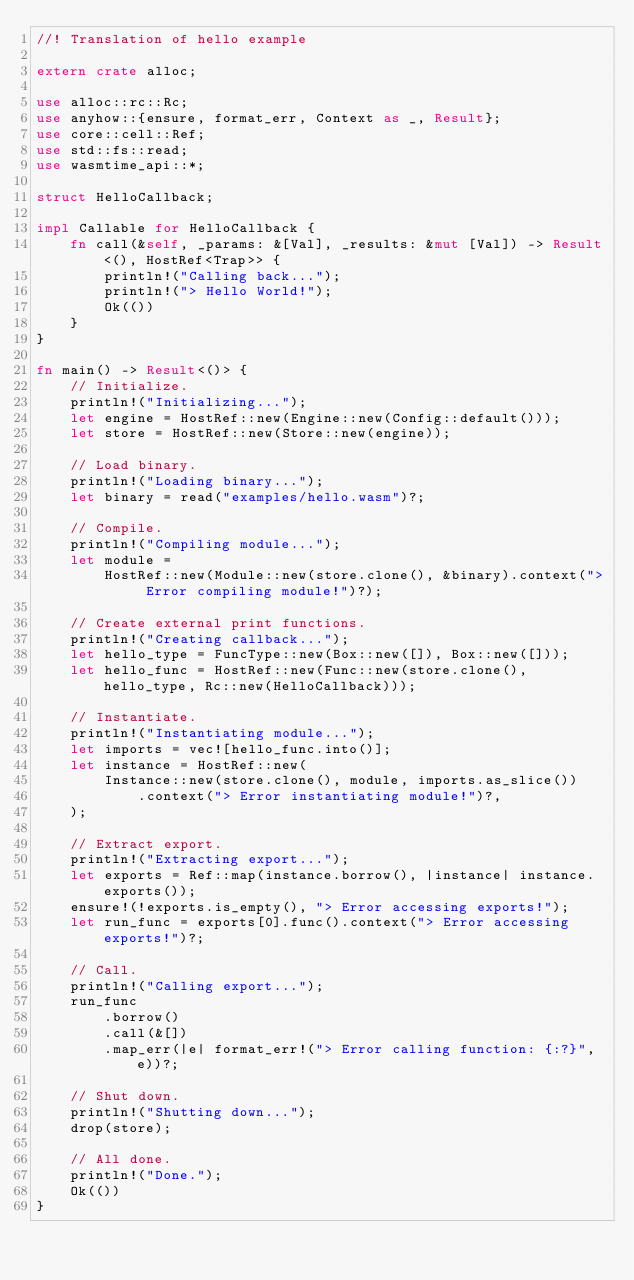<code> <loc_0><loc_0><loc_500><loc_500><_Rust_>//! Translation of hello example

extern crate alloc;

use alloc::rc::Rc;
use anyhow::{ensure, format_err, Context as _, Result};
use core::cell::Ref;
use std::fs::read;
use wasmtime_api::*;

struct HelloCallback;

impl Callable for HelloCallback {
    fn call(&self, _params: &[Val], _results: &mut [Val]) -> Result<(), HostRef<Trap>> {
        println!("Calling back...");
        println!("> Hello World!");
        Ok(())
    }
}

fn main() -> Result<()> {
    // Initialize.
    println!("Initializing...");
    let engine = HostRef::new(Engine::new(Config::default()));
    let store = HostRef::new(Store::new(engine));

    // Load binary.
    println!("Loading binary...");
    let binary = read("examples/hello.wasm")?;

    // Compile.
    println!("Compiling module...");
    let module =
        HostRef::new(Module::new(store.clone(), &binary).context("> Error compiling module!")?);

    // Create external print functions.
    println!("Creating callback...");
    let hello_type = FuncType::new(Box::new([]), Box::new([]));
    let hello_func = HostRef::new(Func::new(store.clone(), hello_type, Rc::new(HelloCallback)));

    // Instantiate.
    println!("Instantiating module...");
    let imports = vec![hello_func.into()];
    let instance = HostRef::new(
        Instance::new(store.clone(), module, imports.as_slice())
            .context("> Error instantiating module!")?,
    );

    // Extract export.
    println!("Extracting export...");
    let exports = Ref::map(instance.borrow(), |instance| instance.exports());
    ensure!(!exports.is_empty(), "> Error accessing exports!");
    let run_func = exports[0].func().context("> Error accessing exports!")?;

    // Call.
    println!("Calling export...");
    run_func
        .borrow()
        .call(&[])
        .map_err(|e| format_err!("> Error calling function: {:?}", e))?;

    // Shut down.
    println!("Shutting down...");
    drop(store);

    // All done.
    println!("Done.");
    Ok(())
}
</code> 